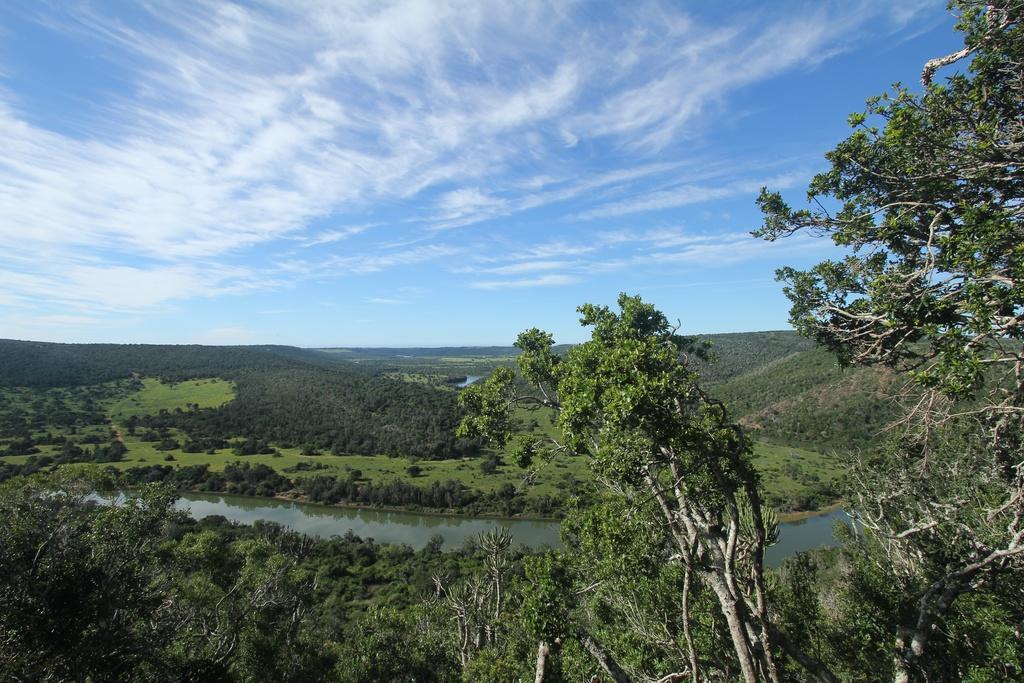How would you summarize this image in a sentence or two? In the image there is a river and around the river there are trees grass and plants. 